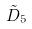<formula> <loc_0><loc_0><loc_500><loc_500>\tilde { D } _ { 5 }</formula> 